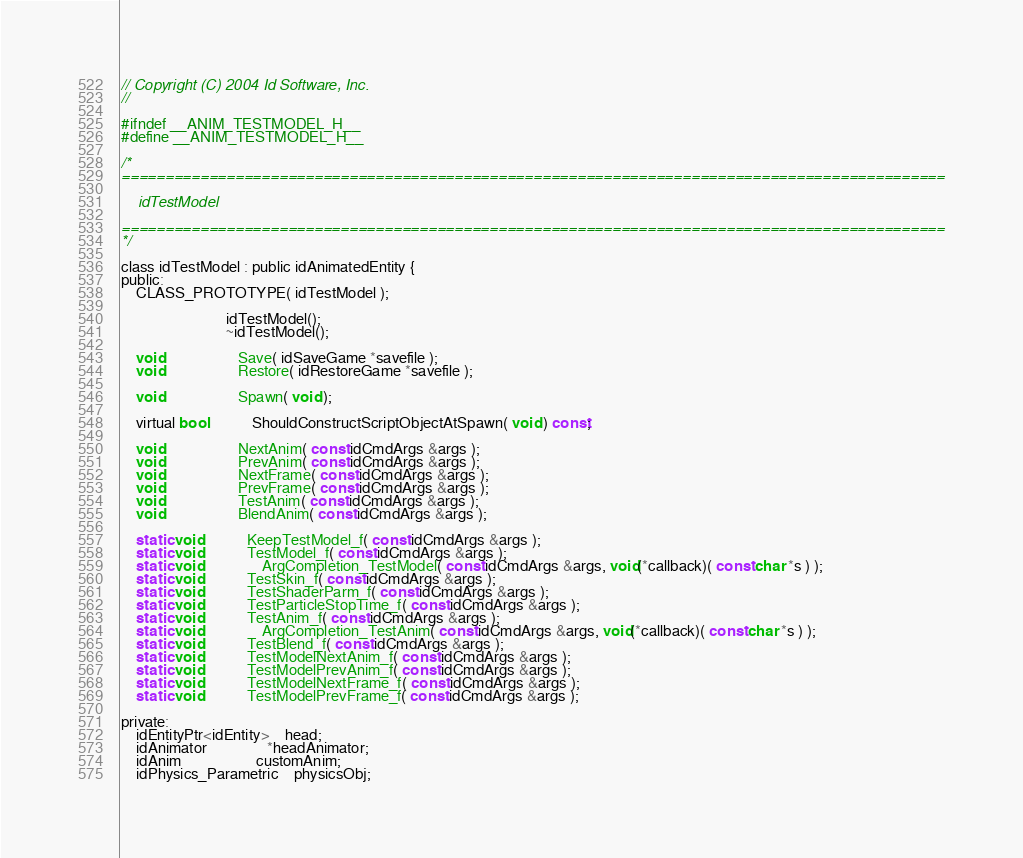Convert code to text. <code><loc_0><loc_0><loc_500><loc_500><_C_>// Copyright (C) 2004 Id Software, Inc.
//

#ifndef __ANIM_TESTMODEL_H__
#define __ANIM_TESTMODEL_H__

/*
==============================================================================================

	idTestModel

==============================================================================================
*/

class idTestModel : public idAnimatedEntity {
public:
	CLASS_PROTOTYPE( idTestModel );

							idTestModel();
							~idTestModel();

	void					Save( idSaveGame *savefile );
	void					Restore( idRestoreGame *savefile );

	void					Spawn( void );

	virtual bool			ShouldConstructScriptObjectAtSpawn( void ) const;

	void					NextAnim( const idCmdArgs &args );
	void					PrevAnim( const idCmdArgs &args );
	void					NextFrame( const idCmdArgs &args );
	void					PrevFrame( const idCmdArgs &args );
	void					TestAnim( const idCmdArgs &args );
	void					BlendAnim( const idCmdArgs &args );

	static void 			KeepTestModel_f( const idCmdArgs &args );
	static void 			TestModel_f( const idCmdArgs &args );
	static void				ArgCompletion_TestModel( const idCmdArgs &args, void(*callback)( const char *s ) );
	static void 			TestSkin_f( const idCmdArgs &args );
	static void 			TestShaderParm_f( const idCmdArgs &args );
	static void 			TestParticleStopTime_f( const idCmdArgs &args );
	static void 			TestAnim_f( const idCmdArgs &args );
	static void				ArgCompletion_TestAnim( const idCmdArgs &args, void(*callback)( const char *s ) );
	static void 			TestBlend_f( const idCmdArgs &args );
	static void 			TestModelNextAnim_f( const idCmdArgs &args );
	static void 			TestModelPrevAnim_f( const idCmdArgs &args );
	static void 			TestModelNextFrame_f( const idCmdArgs &args );
	static void 			TestModelPrevFrame_f( const idCmdArgs &args );

private:
	idEntityPtr<idEntity>	head;
	idAnimator				*headAnimator;
	idAnim					customAnim;
	idPhysics_Parametric	physicsObj;</code> 